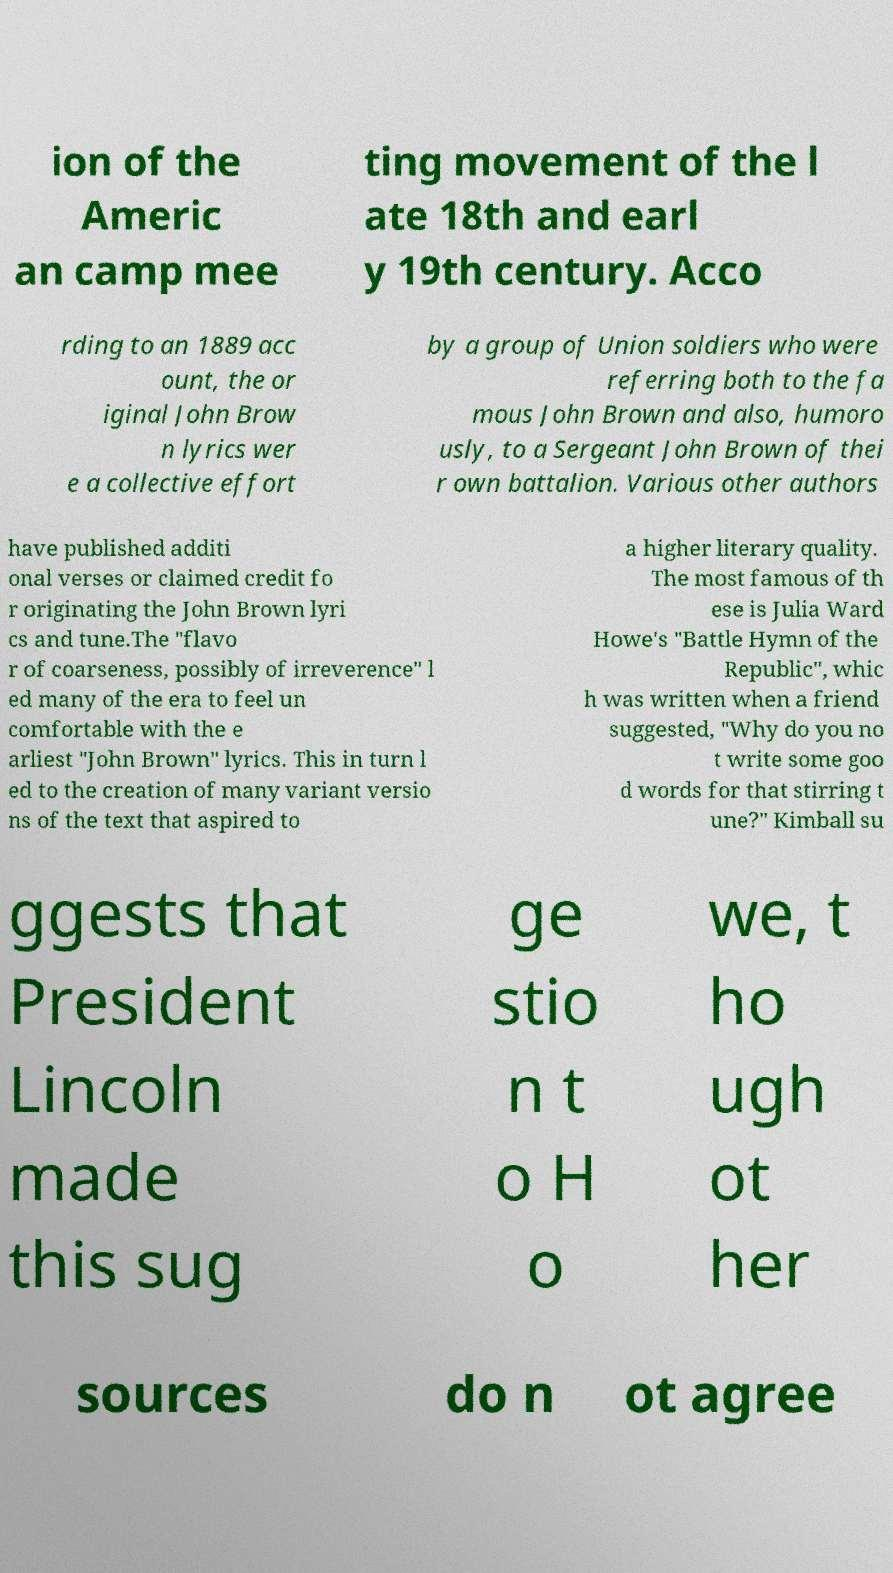For documentation purposes, I need the text within this image transcribed. Could you provide that? ion of the Americ an camp mee ting movement of the l ate 18th and earl y 19th century. Acco rding to an 1889 acc ount, the or iginal John Brow n lyrics wer e a collective effort by a group of Union soldiers who were referring both to the fa mous John Brown and also, humoro usly, to a Sergeant John Brown of thei r own battalion. Various other authors have published additi onal verses or claimed credit fo r originating the John Brown lyri cs and tune.The "flavo r of coarseness, possibly of irreverence" l ed many of the era to feel un comfortable with the e arliest "John Brown" lyrics. This in turn l ed to the creation of many variant versio ns of the text that aspired to a higher literary quality. The most famous of th ese is Julia Ward Howe's "Battle Hymn of the Republic", whic h was written when a friend suggested, "Why do you no t write some goo d words for that stirring t une?" Kimball su ggests that President Lincoln made this sug ge stio n t o H o we, t ho ugh ot her sources do n ot agree 